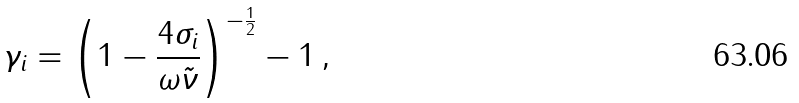<formula> <loc_0><loc_0><loc_500><loc_500>\gamma _ { i } = \left ( 1 - \frac { 4 \sigma _ { i } } { \omega \tilde { \nu } } \right ) ^ { - \frac { 1 } { 2 } } - 1 \, ,</formula> 